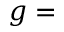Convert formula to latex. <formula><loc_0><loc_0><loc_500><loc_500>g =</formula> 